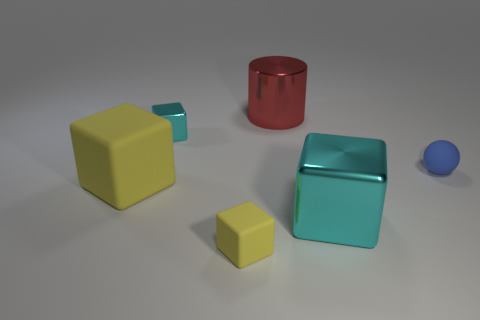Subtract all large metal blocks. How many blocks are left? 3 Subtract all brown cubes. Subtract all red cylinders. How many cubes are left? 4 Add 2 red cylinders. How many objects exist? 8 Subtract all spheres. How many objects are left? 5 Subtract 0 brown cylinders. How many objects are left? 6 Subtract all cyan shiny blocks. Subtract all metallic things. How many objects are left? 1 Add 2 large red metallic things. How many large red metallic things are left? 3 Add 5 big cyan cubes. How many big cyan cubes exist? 6 